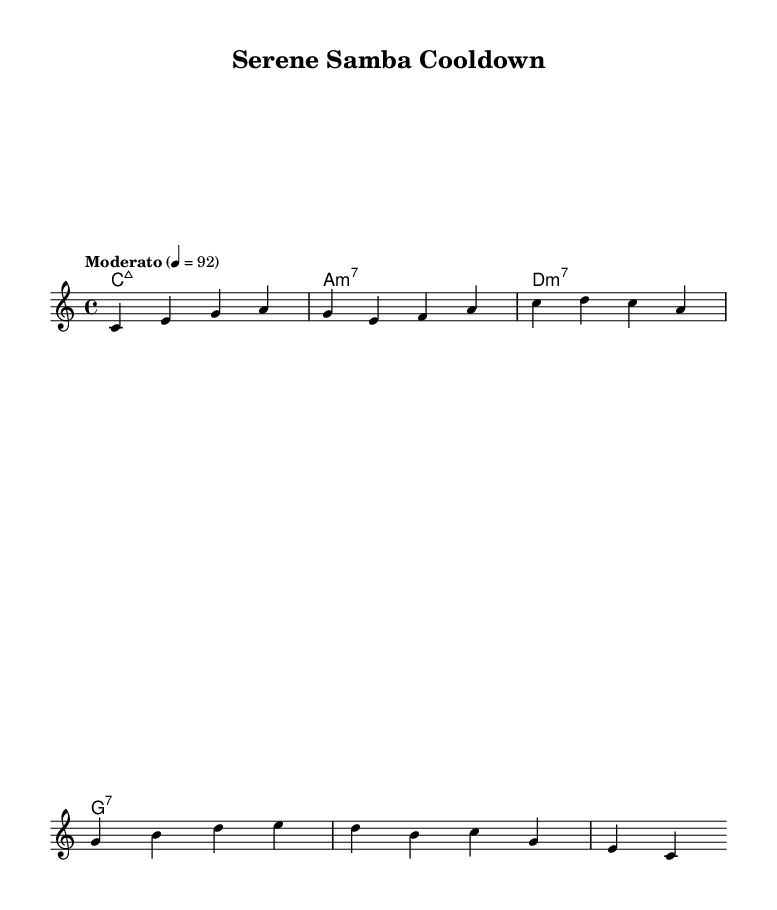What is the key signature of this music? The key signature is indicated by the absence of any sharps or flats, which means it is in the key of C major.
Answer: C major What is the time signature of this piece? The time signature is represented at the beginning of the piece and is shown as '4/4', indicating four beats per measure.
Answer: 4/4 What is the tempo marking for this music? The tempo marking is specified at the beginning with the word "Moderato," followed by a metronome marking of 4 = 92, which indicates a moderate speed.
Answer: Moderato How many measures are there in the melody? The melody section contains four distinct measures as seen by the grouping of notes separated by vertical lines.
Answer: 4 What type of seventh chord is used at the beginning? The first chord in the harmonies section is labeled "C:maj7," indicating it is a major seventh chord in C major.
Answer: Major seventh What kind of feel or style might this music's genre evoke? Latin jazz fusion typically combines elements of jazz and Latin music, conveying rhythmic complexity and cultural influences, great for relaxation.
Answer: Relaxation What is the last note of the melody? The final note in the melody, after following the notes in the staff and identifying the last position, is 'C.'
Answer: C 